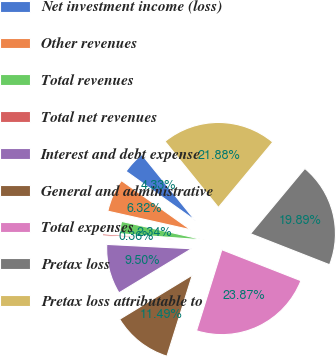Convert chart to OTSL. <chart><loc_0><loc_0><loc_500><loc_500><pie_chart><fcel>Net investment income (loss)<fcel>Other revenues<fcel>Total revenues<fcel>Total net revenues<fcel>Interest and debt expense<fcel>General and administrative<fcel>Total expenses<fcel>Pretax loss<fcel>Pretax loss attributable to<nl><fcel>4.33%<fcel>6.32%<fcel>2.34%<fcel>0.36%<fcel>9.5%<fcel>11.49%<fcel>23.87%<fcel>19.89%<fcel>21.88%<nl></chart> 